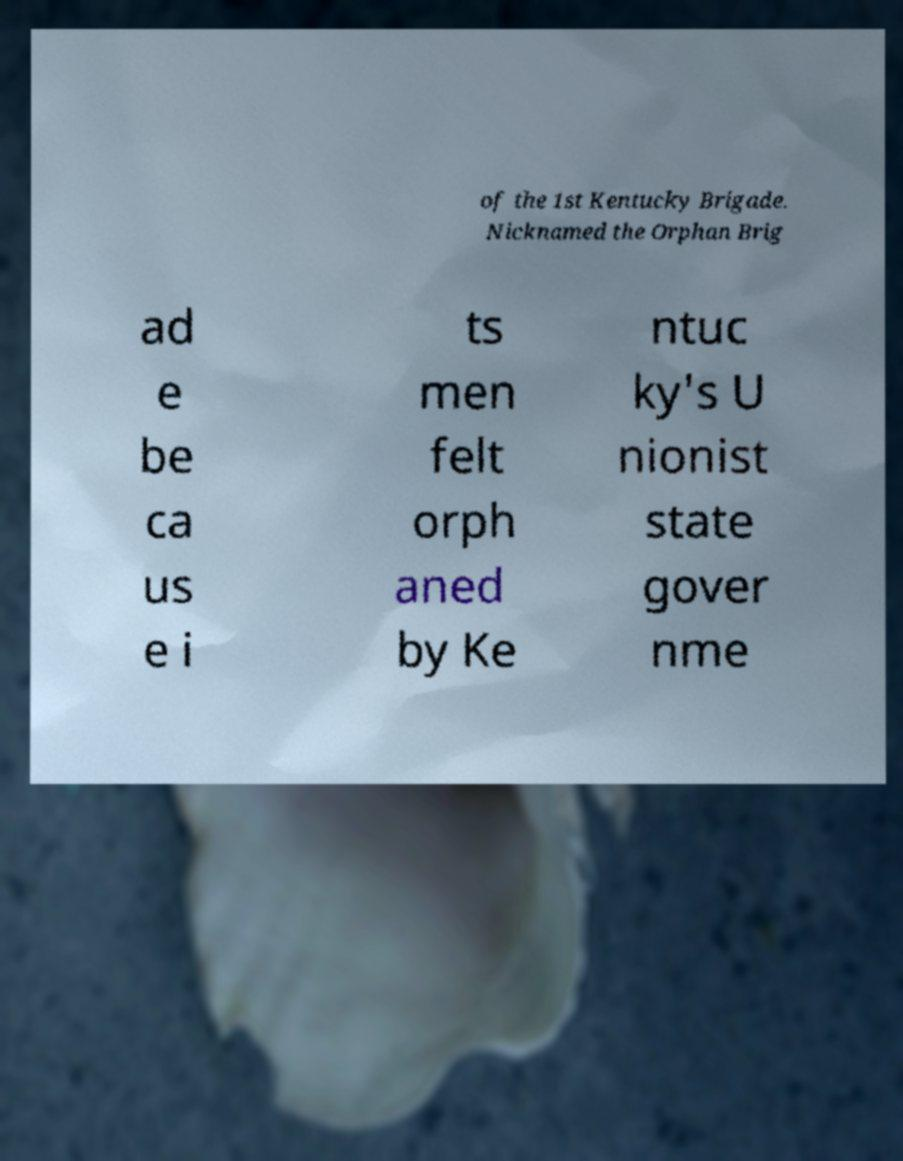Please read and relay the text visible in this image. What does it say? of the 1st Kentucky Brigade. Nicknamed the Orphan Brig ad e be ca us e i ts men felt orph aned by Ke ntuc ky's U nionist state gover nme 